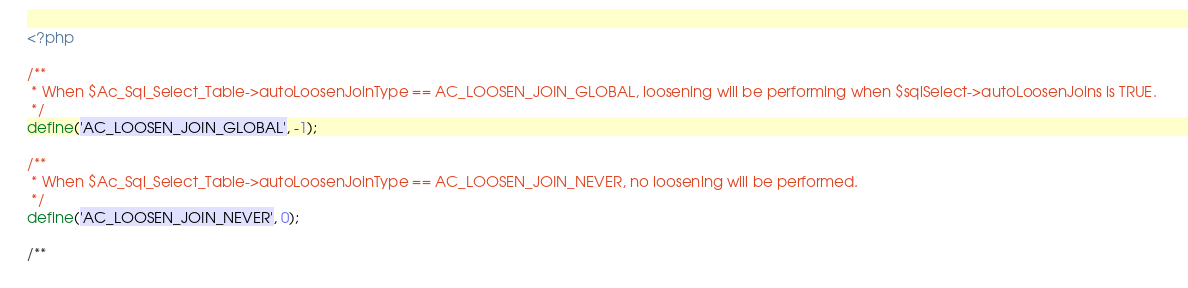Convert code to text. <code><loc_0><loc_0><loc_500><loc_500><_PHP_><?php

/**
 * When $Ac_Sql_Select_Table->autoLoosenJoinType == AC_LOOSEN_JOIN_GLOBAL, loosening will be performing when $sqlSelect->autoLoosenJoins is TRUE. 
 */
define('AC_LOOSEN_JOIN_GLOBAL', -1);

/**
 * When $Ac_Sql_Select_Table->autoLoosenJoinType == AC_LOOSEN_JOIN_NEVER, no loosening will be performed. 
 */
define('AC_LOOSEN_JOIN_NEVER', 0);

/**</code> 